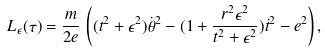<formula> <loc_0><loc_0><loc_500><loc_500>L _ { \epsilon } ( \tau ) = \frac { m } { 2 e } \, \left ( ( t ^ { 2 } + \epsilon ^ { 2 } ) \dot { \theta } ^ { 2 } - ( 1 + \frac { r ^ { 2 } \epsilon ^ { 2 } } { t ^ { 2 } + \epsilon ^ { 2 } } ) \dot { t } ^ { 2 } - e ^ { 2 } \right ) ,</formula> 